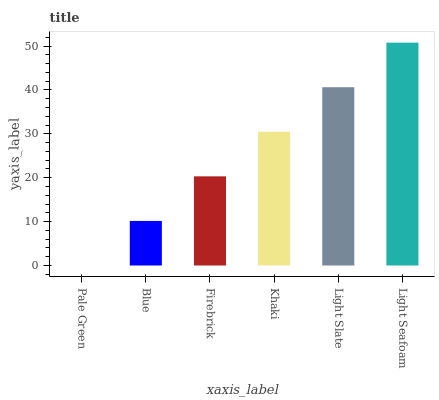Is Pale Green the minimum?
Answer yes or no. Yes. Is Light Seafoam the maximum?
Answer yes or no. Yes. Is Blue the minimum?
Answer yes or no. No. Is Blue the maximum?
Answer yes or no. No. Is Blue greater than Pale Green?
Answer yes or no. Yes. Is Pale Green less than Blue?
Answer yes or no. Yes. Is Pale Green greater than Blue?
Answer yes or no. No. Is Blue less than Pale Green?
Answer yes or no. No. Is Khaki the high median?
Answer yes or no. Yes. Is Firebrick the low median?
Answer yes or no. Yes. Is Firebrick the high median?
Answer yes or no. No. Is Khaki the low median?
Answer yes or no. No. 